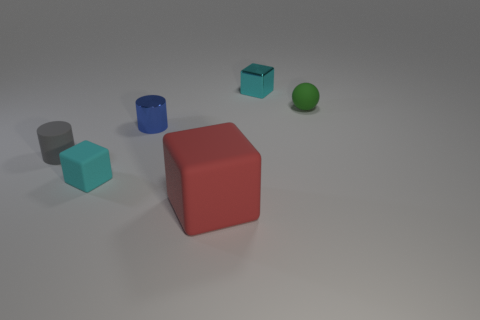Add 1 big red cubes. How many objects exist? 7 Subtract all spheres. How many objects are left? 5 Add 3 blue shiny things. How many blue shiny things are left? 4 Add 6 tiny spheres. How many tiny spheres exist? 7 Subtract 2 cyan cubes. How many objects are left? 4 Subtract all large gray metallic balls. Subtract all big matte blocks. How many objects are left? 5 